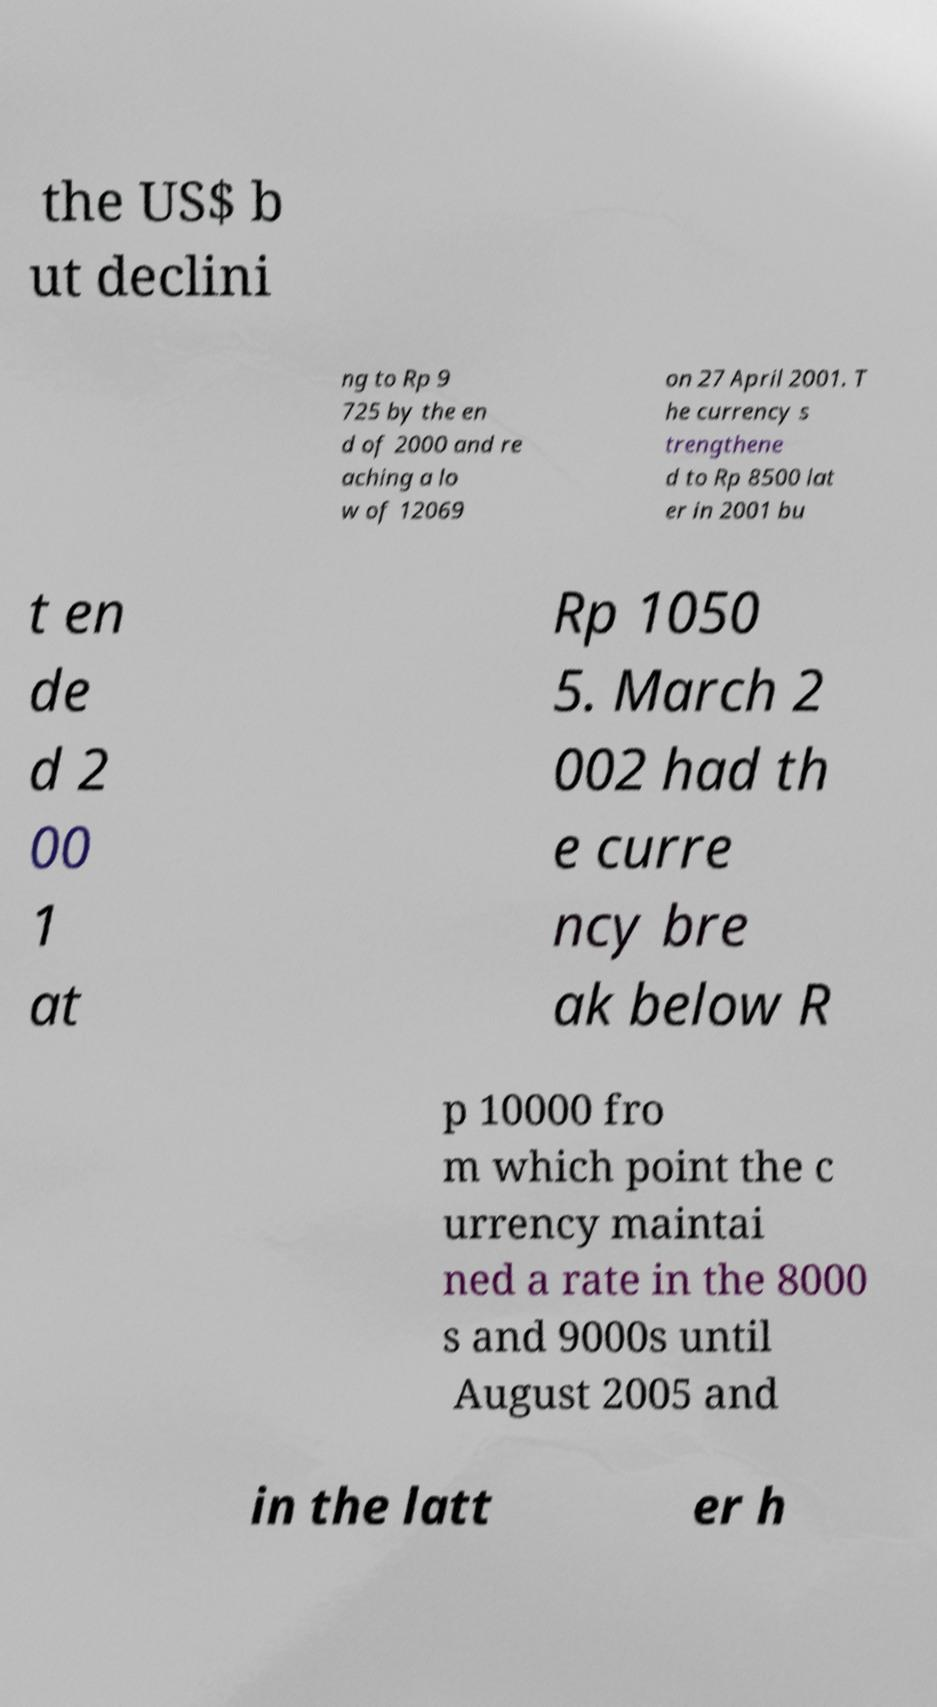Can you read and provide the text displayed in the image?This photo seems to have some interesting text. Can you extract and type it out for me? the US$ b ut declini ng to Rp 9 725 by the en d of 2000 and re aching a lo w of 12069 on 27 April 2001. T he currency s trengthene d to Rp 8500 lat er in 2001 bu t en de d 2 00 1 at Rp 1050 5. March 2 002 had th e curre ncy bre ak below R p 10000 fro m which point the c urrency maintai ned a rate in the 8000 s and 9000s until August 2005 and in the latt er h 